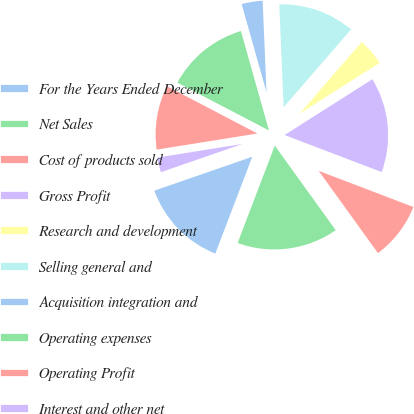Convert chart. <chart><loc_0><loc_0><loc_500><loc_500><pie_chart><fcel>For the Years Ended December<fcel>Net Sales<fcel>Cost of products sold<fcel>Gross Profit<fcel>Research and development<fcel>Selling general and<fcel>Acquisition integration and<fcel>Operating expenses<fcel>Operating Profit<fcel>Interest and other net<nl><fcel>13.89%<fcel>15.74%<fcel>9.26%<fcel>14.81%<fcel>4.63%<fcel>12.04%<fcel>3.7%<fcel>12.96%<fcel>10.19%<fcel>2.78%<nl></chart> 